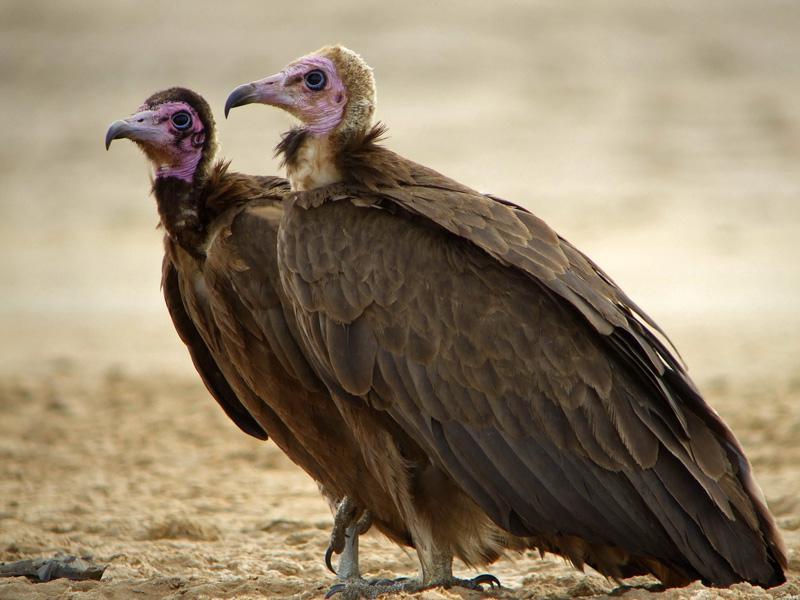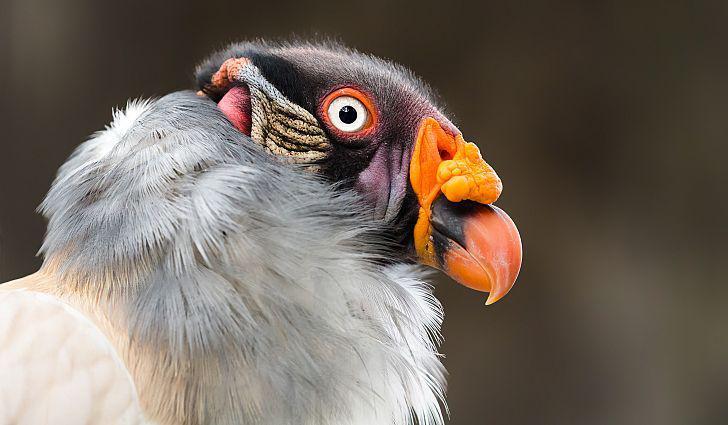The first image is the image on the left, the second image is the image on the right. Examine the images to the left and right. Is the description "A bird has a raised wing in one image." accurate? Answer yes or no. No. 